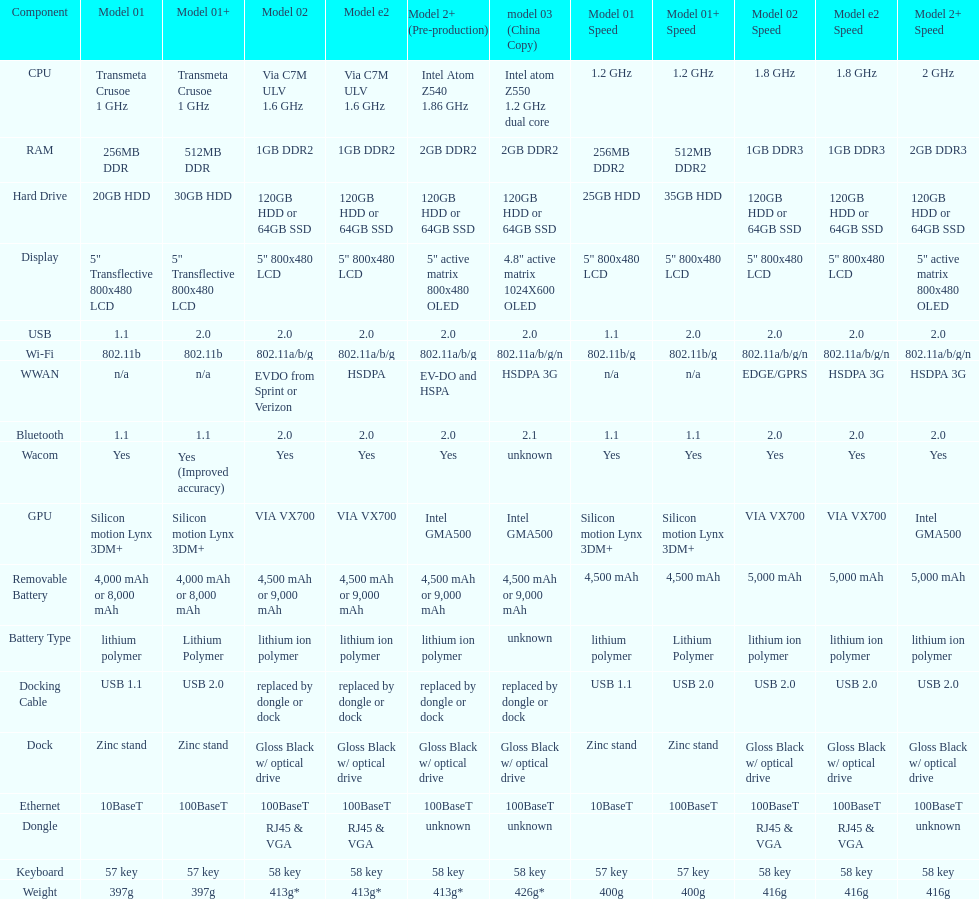What is the component before usb? Display. 